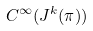Convert formula to latex. <formula><loc_0><loc_0><loc_500><loc_500>C ^ { \infty } ( J ^ { k } ( \pi ) )</formula> 